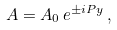Convert formula to latex. <formula><loc_0><loc_0><loc_500><loc_500>A = A _ { 0 } \, e ^ { \pm i P y } \, ,</formula> 